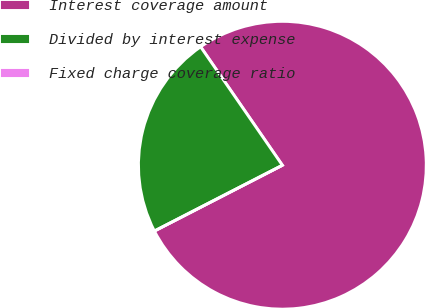<chart> <loc_0><loc_0><loc_500><loc_500><pie_chart><fcel>Interest coverage amount<fcel>Divided by interest expense<fcel>Fixed charge coverage ratio<nl><fcel>77.06%<fcel>22.94%<fcel>0.0%<nl></chart> 